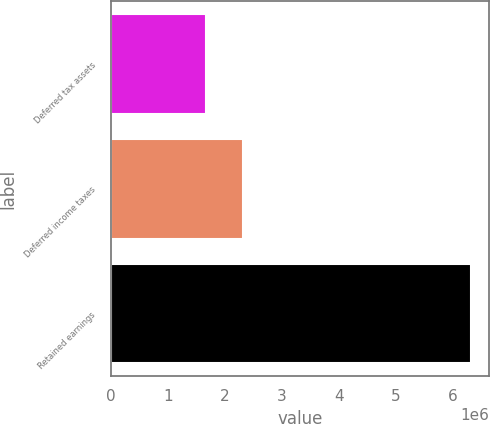Convert chart to OTSL. <chart><loc_0><loc_0><loc_500><loc_500><bar_chart><fcel>Deferred tax assets<fcel>Deferred income taxes<fcel>Retained earnings<nl><fcel>1.66479e+06<fcel>2.31451e+06<fcel>6.31372e+06<nl></chart> 